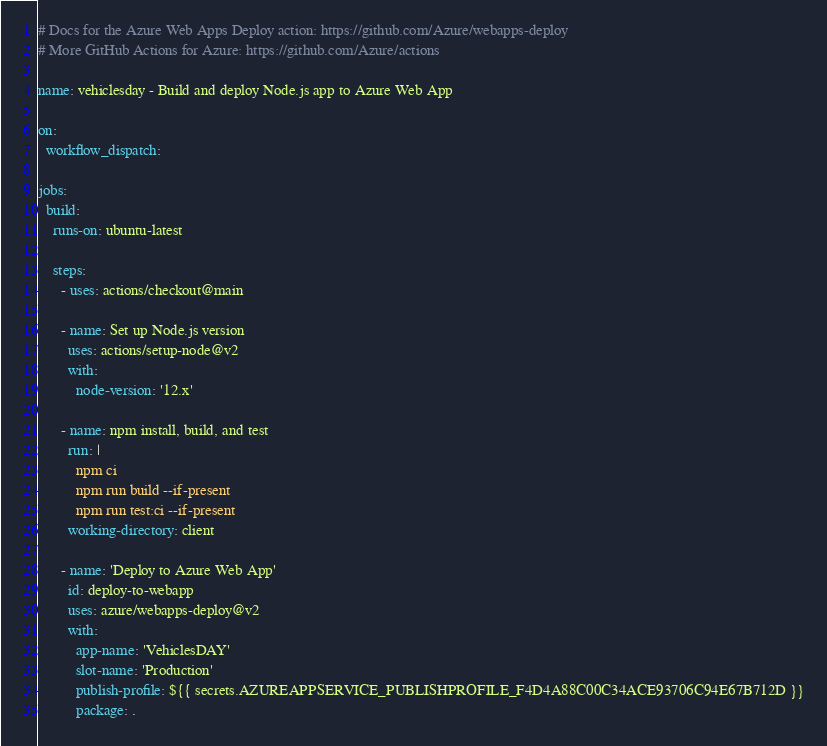Convert code to text. <code><loc_0><loc_0><loc_500><loc_500><_YAML_># Docs for the Azure Web Apps Deploy action: https://github.com/Azure/webapps-deploy
# More GitHub Actions for Azure: https://github.com/Azure/actions

name: vehiclesday - Build and deploy Node.js app to Azure Web App

on:
  workflow_dispatch:

jobs:
  build:
    runs-on: ubuntu-latest

    steps:
      - uses: actions/checkout@main

      - name: Set up Node.js version
        uses: actions/setup-node@v2
        with:
          node-version: '12.x'

      - name: npm install, build, and test
        run: |
          npm ci
          npm run build --if-present
          npm run test:ci --if-present
        working-directory: client

      - name: 'Deploy to Azure Web App'
        id: deploy-to-webapp
        uses: azure/webapps-deploy@v2
        with:
          app-name: 'VehiclesDAY'
          slot-name: 'Production'
          publish-profile: ${{ secrets.AZUREAPPSERVICE_PUBLISHPROFILE_F4D4A88C00C34ACE93706C94E67B712D }}
          package: .
</code> 